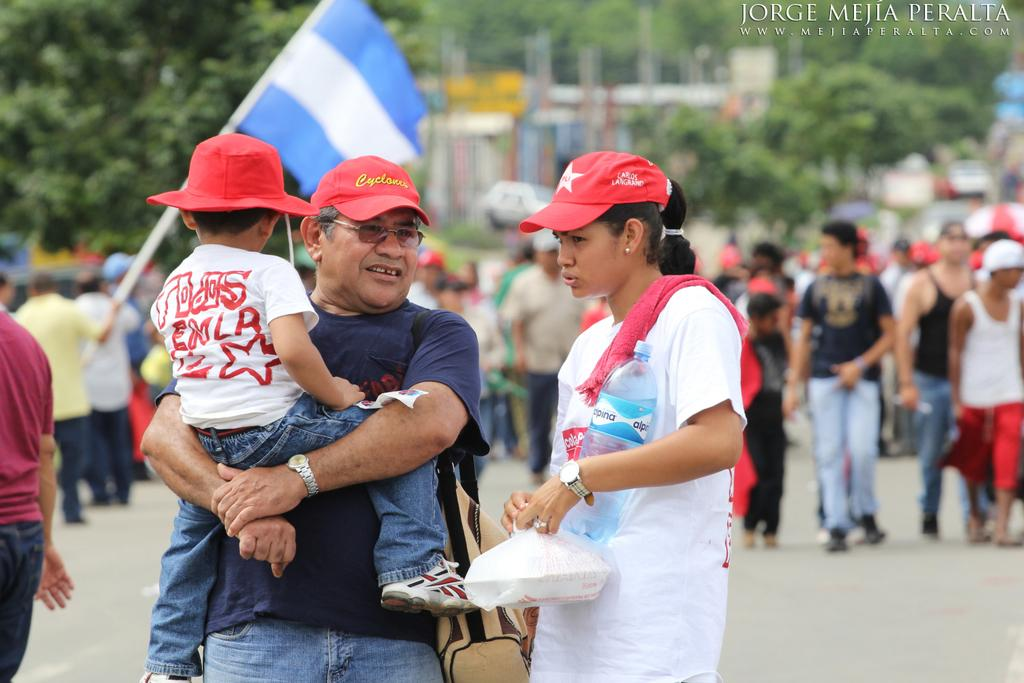How many people are present in the image? There are people in the image, but the exact number is not specified. What are some of the people holding in the image? Some people are holding objects in the image. What can be seen in the background of the image? There are trees and a building in the background of the image. What is the purpose of the flag in the image? The purpose of the flag in the image is not specified, but it may represent a country, organization, or event. What type of wrench is being used to fix the current issue in the image? There is no wrench or current issue present in the image. What class are the people attending in the image? There is no indication of a class or educational setting in the image. 